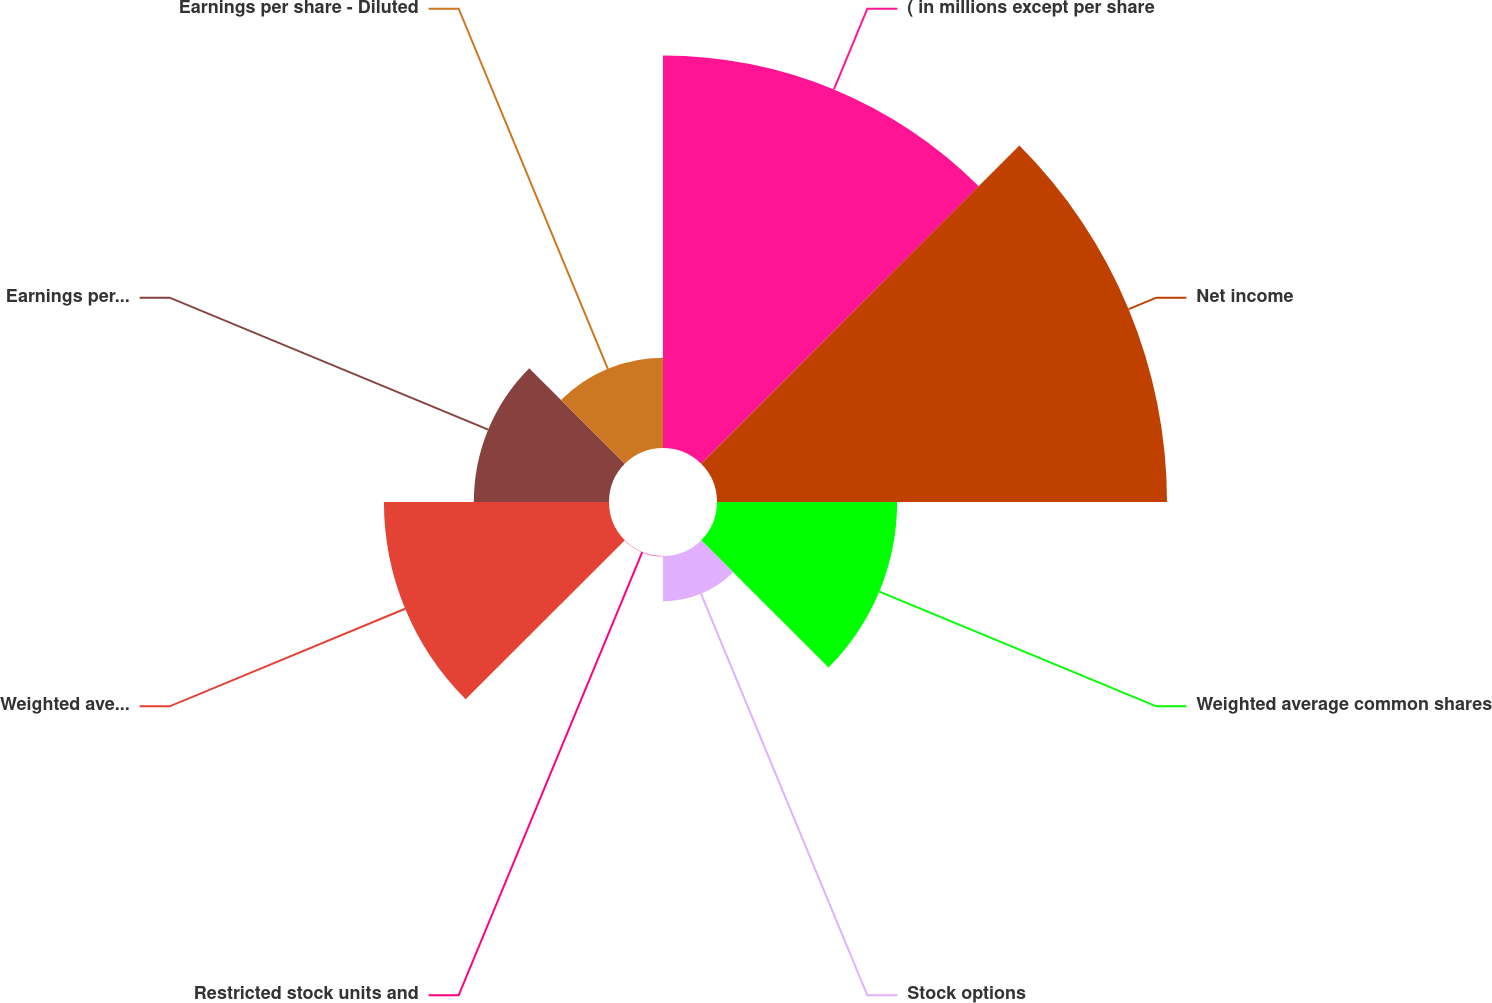<chart> <loc_0><loc_0><loc_500><loc_500><pie_chart><fcel>( in millions except per share<fcel>Net income<fcel>Weighted average common shares<fcel>Stock options<fcel>Restricted stock units and<fcel>Weighted average common and<fcel>Earnings per share - Basic<fcel>Earnings per share - Diluted<nl><fcel>25.85%<fcel>29.63%<fcel>11.86%<fcel>2.98%<fcel>0.02%<fcel>14.82%<fcel>8.9%<fcel>5.94%<nl></chart> 